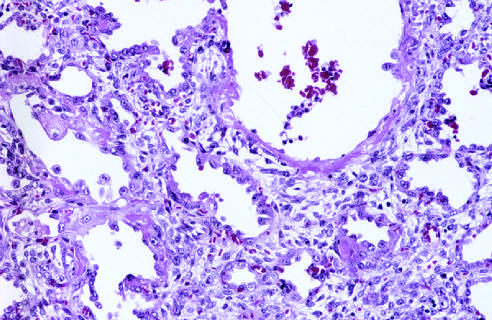what is the healing stage marked by?
Answer the question using a single word or phrase. Resorption of hyaline membranes and thickening of alveolar septa by inflammatory cells 